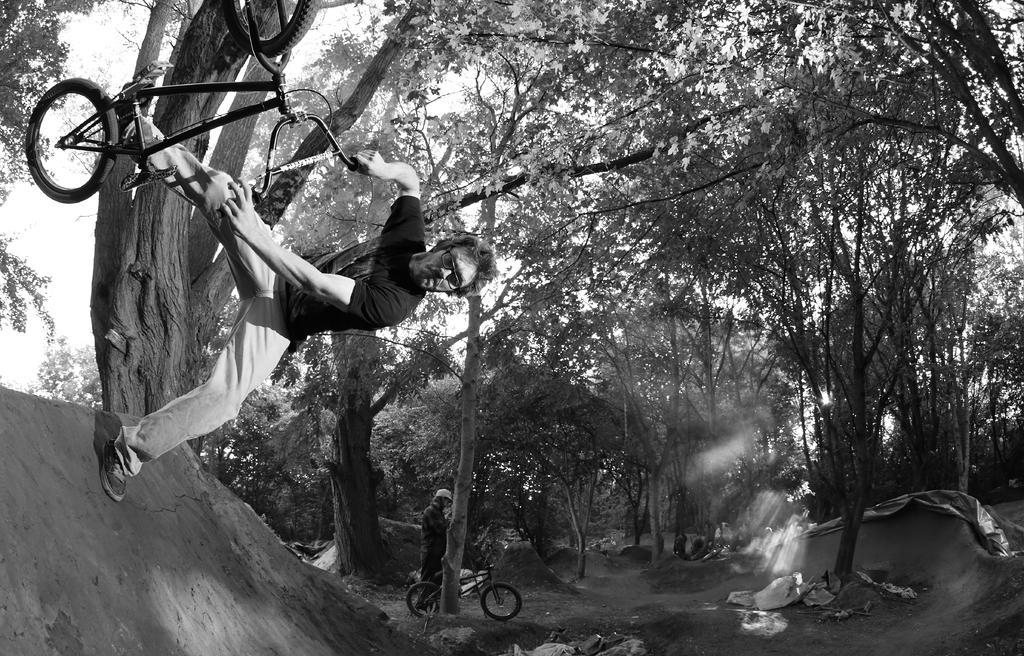Could you give a brief overview of what you see in this image? Here in the front we can see a person performing stunts on a bicycle and behind him we can see number of trees and there are also other people with bicycles here 